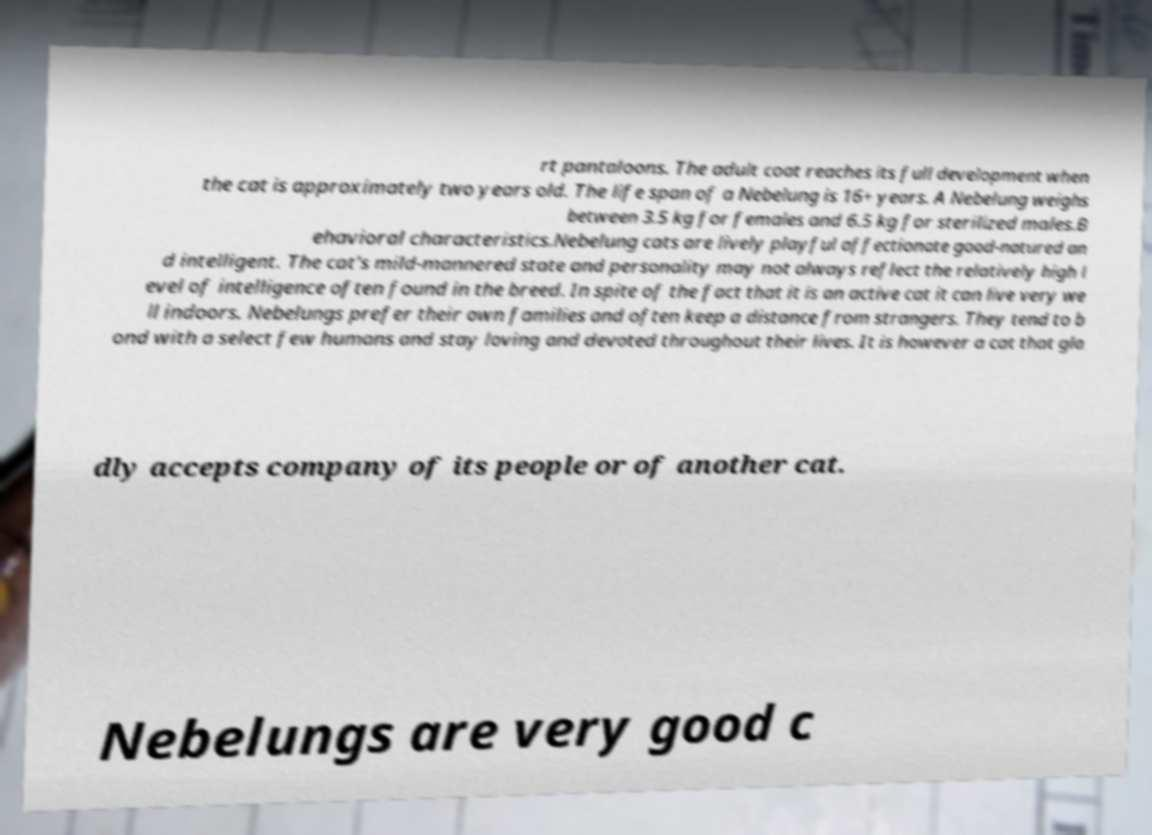Could you extract and type out the text from this image? rt pantaloons. The adult coat reaches its full development when the cat is approximately two years old. The life span of a Nebelung is 16+ years. A Nebelung weighs between 3.5 kg for females and 6.5 kg for sterilized males.B ehavioral characteristics.Nebelung cats are lively playful affectionate good-natured an d intelligent. The cat's mild-mannered state and personality may not always reflect the relatively high l evel of intelligence often found in the breed. In spite of the fact that it is an active cat it can live very we ll indoors. Nebelungs prefer their own families and often keep a distance from strangers. They tend to b ond with a select few humans and stay loving and devoted throughout their lives. It is however a cat that gla dly accepts company of its people or of another cat. Nebelungs are very good c 